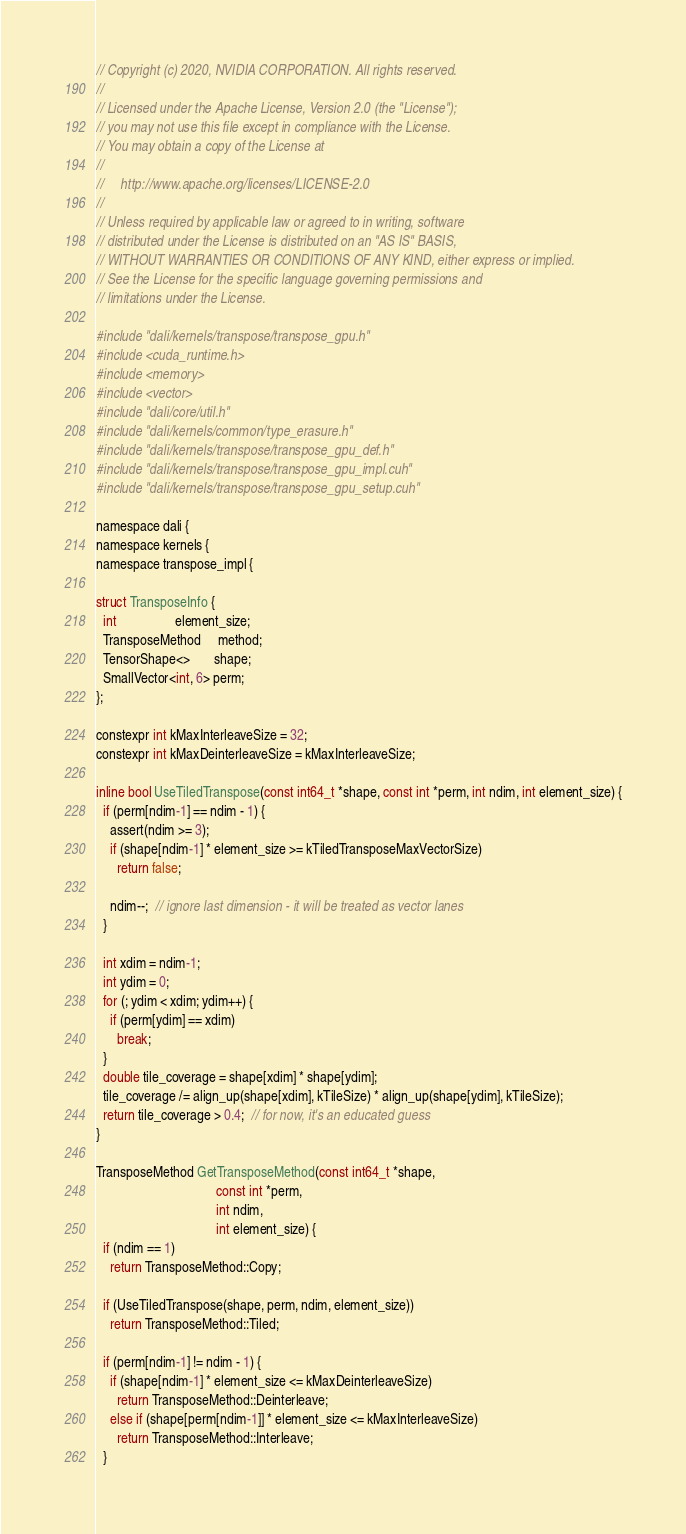Convert code to text. <code><loc_0><loc_0><loc_500><loc_500><_Cuda_>// Copyright (c) 2020, NVIDIA CORPORATION. All rights reserved.
//
// Licensed under the Apache License, Version 2.0 (the "License");
// you may not use this file except in compliance with the License.
// You may obtain a copy of the License at
//
//     http://www.apache.org/licenses/LICENSE-2.0
//
// Unless required by applicable law or agreed to in writing, software
// distributed under the License is distributed on an "AS IS" BASIS,
// WITHOUT WARRANTIES OR CONDITIONS OF ANY KIND, either express or implied.
// See the License for the specific language governing permissions and
// limitations under the License.

#include "dali/kernels/transpose/transpose_gpu.h"
#include <cuda_runtime.h>
#include <memory>
#include <vector>
#include "dali/core/util.h"
#include "dali/kernels/common/type_erasure.h"
#include "dali/kernels/transpose/transpose_gpu_def.h"
#include "dali/kernels/transpose/transpose_gpu_impl.cuh"
#include "dali/kernels/transpose/transpose_gpu_setup.cuh"

namespace dali {
namespace kernels {
namespace transpose_impl {

struct TransposeInfo {
  int                 element_size;
  TransposeMethod     method;
  TensorShape<>       shape;
  SmallVector<int, 6> perm;
};

constexpr int kMaxInterleaveSize = 32;
constexpr int kMaxDeinterleaveSize = kMaxInterleaveSize;

inline bool UseTiledTranspose(const int64_t *shape, const int *perm, int ndim, int element_size) {
  if (perm[ndim-1] == ndim - 1) {
    assert(ndim >= 3);
    if (shape[ndim-1] * element_size >= kTiledTransposeMaxVectorSize)
      return false;

    ndim--;  // ignore last dimension - it will be treated as vector lanes
  }

  int xdim = ndim-1;
  int ydim = 0;
  for (; ydim < xdim; ydim++) {
    if (perm[ydim] == xdim)
      break;
  }
  double tile_coverage = shape[xdim] * shape[ydim];
  tile_coverage /= align_up(shape[xdim], kTileSize) * align_up(shape[ydim], kTileSize);
  return tile_coverage > 0.4;  // for now, it's an educated guess
}

TransposeMethod GetTransposeMethod(const int64_t *shape,
                                   const int *perm,
                                   int ndim,
                                   int element_size) {
  if (ndim == 1)
    return TransposeMethod::Copy;

  if (UseTiledTranspose(shape, perm, ndim, element_size))
    return TransposeMethod::Tiled;

  if (perm[ndim-1] != ndim - 1) {
    if (shape[ndim-1] * element_size <= kMaxDeinterleaveSize)
      return TransposeMethod::Deinterleave;
    else if (shape[perm[ndim-1]] * element_size <= kMaxInterleaveSize)
      return TransposeMethod::Interleave;
  }
</code> 